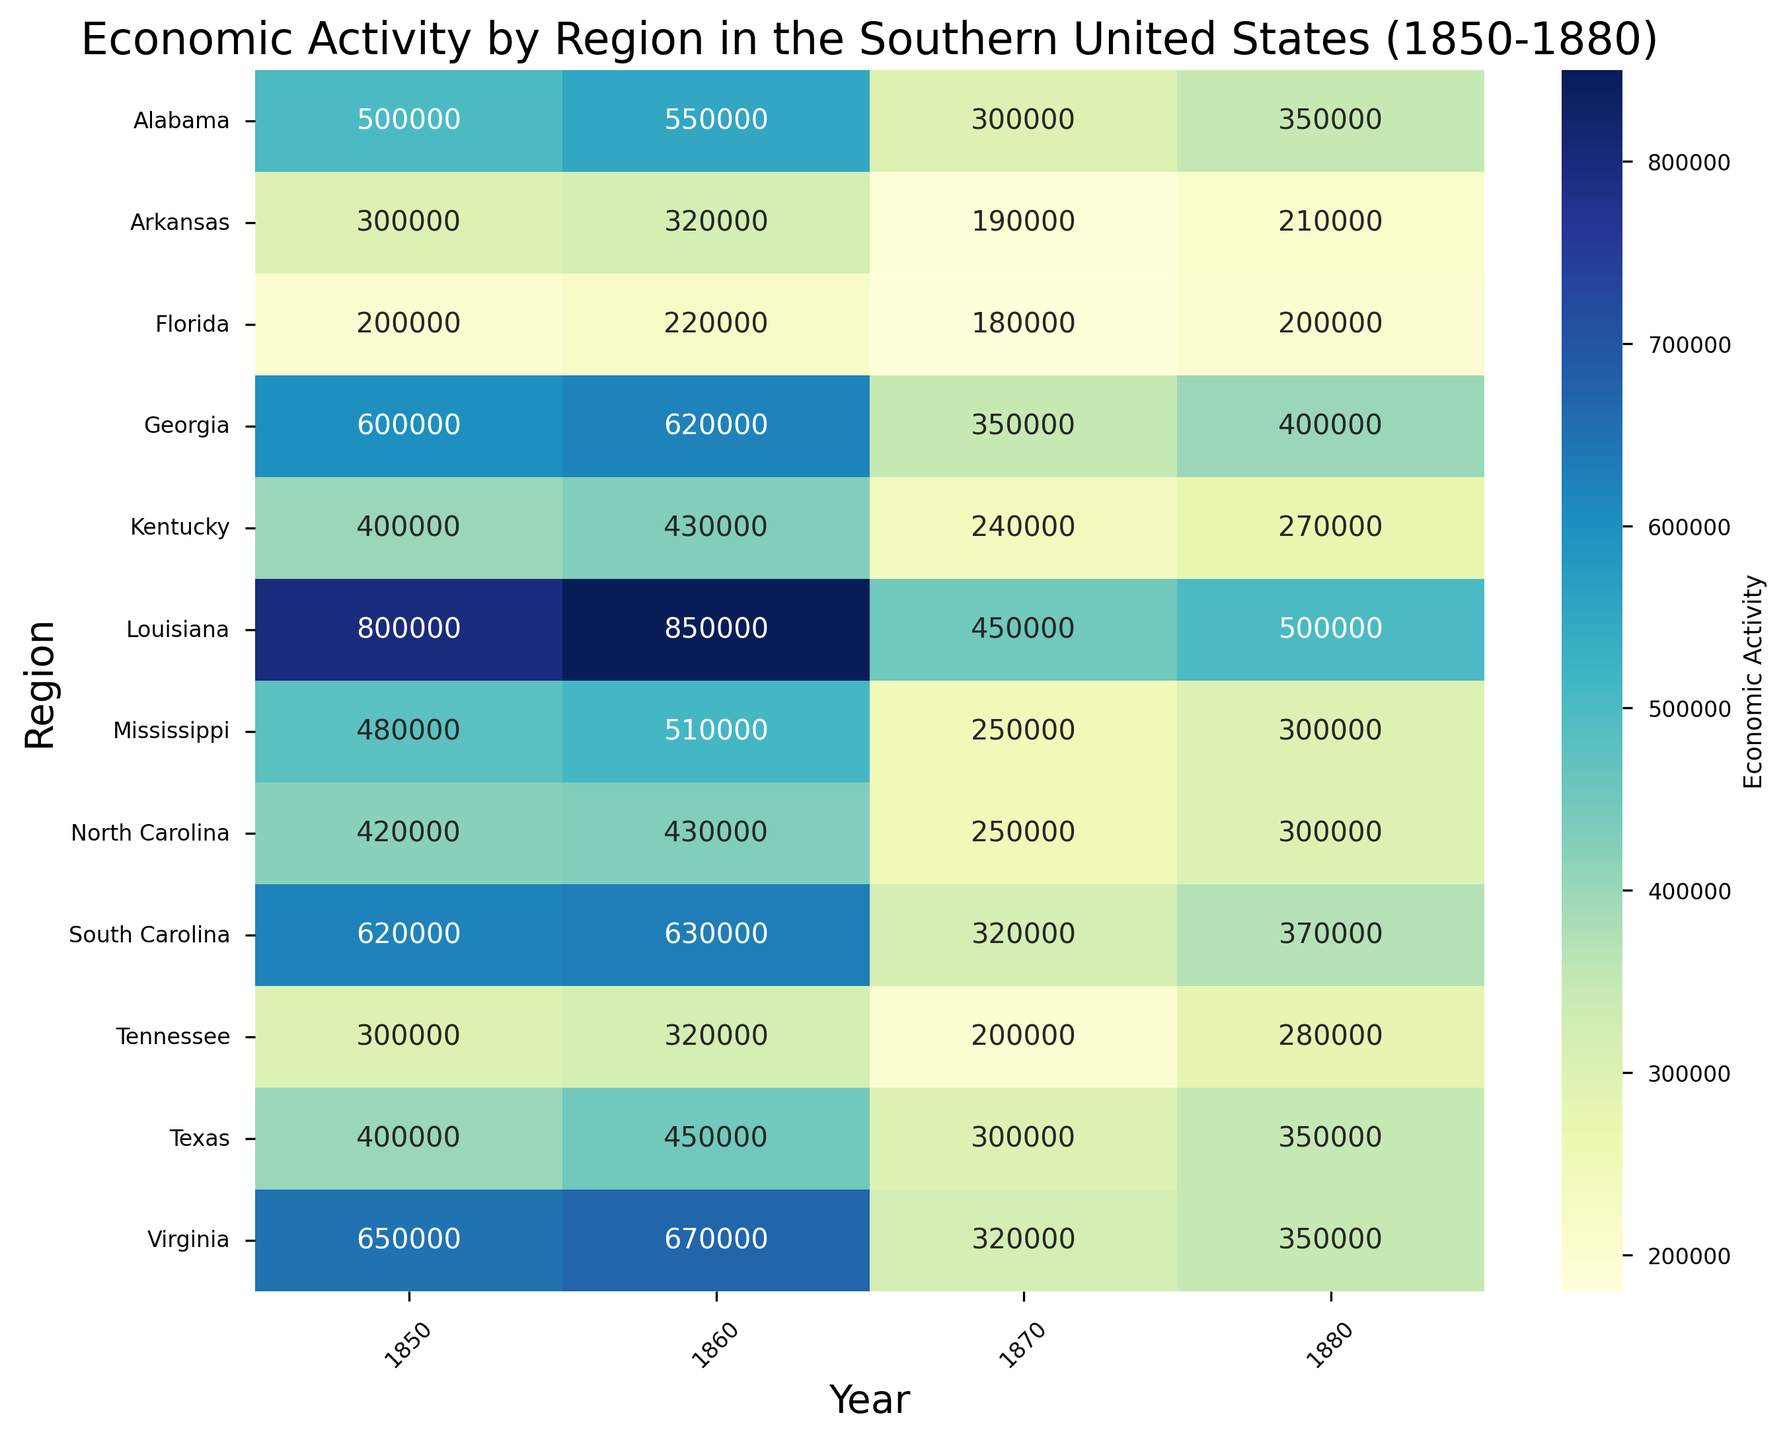What's the economic activity value in Georgia in 1860? Look at the cell corresponding to Georgia and the year 1860. The cell value indicates the economic activity.
Answer: 620000 Which region showed the highest economic activity in 1880? Identify the highest numerical value in the 1880 column and then find the corresponding region name on the y-axis.
Answer: Louisiana What's the difference in economic activity for Alabama between 1860 and 1870? Subtract the value in 1870 from the value in 1860 for Alabama. Alabama's value in 1860 is 550000 and in 1870 is 300000. The difference is 550000 - 300000.
Answer: 250000 Which region experienced the largest drop in economic activity from 1860 to 1870? For each region, subtract the 1870 value from the 1860 value and identify the largest negative difference. Largest drop is seen in Louisiana: 850000 - 450000.
Answer: Louisiana What's the average economic activity of Virginia between 1850 and 1880? Add Virginia's values for each year (650000 + 670000 + 320000 + 350000) and then divide by the number of years (4). (650000 + 670000 + 320000 + 350000) / 4.
Answer: 497500 Which region had the lowest economic activity in 1870? Identify the smallest numerical value in the 1870 column and find the corresponding region name on the y-axis.
Answer: Arkansas How does the economic activity of Tennessee in 1880 compare to that in 1850? Compare the values for Tennessee in the years 1850 (300000) and 1880 (280000). Tennessee's economic activity decreased from 300000 to 280000.
Answer: Decreased What is the color representing the highest value and its region? The deepest color (darkest blue) represents the highest value. Verify it along the color bar legend and find the corresponding cell with the highest numeric value. This value is 850000 in Louisiana.
Answer: Dark blue, Louisiana What's the total economic activity in Texas over all recorded years? Sum the economic activity values for Texas across all the years: 400000 + 450000 + 300000 + 350000. The total is (400000 + 450000 + 300000 + 350000).
Answer: 1500000 